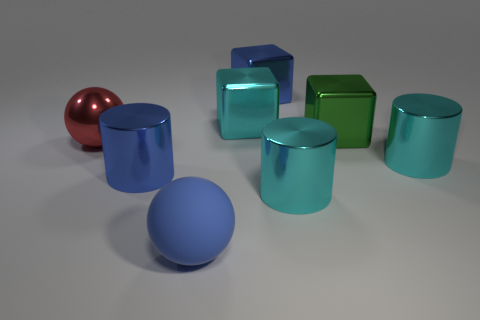Are there more small blocks than green blocks?
Your answer should be compact. No. Are there more things that are in front of the big cyan metallic cube than big red shiny spheres behind the large red metal ball?
Provide a short and direct response. Yes. There is a metallic cube that is both right of the cyan shiny block and in front of the big blue metal block; how big is it?
Provide a short and direct response. Large. How many cyan metal cylinders are the same size as the green cube?
Keep it short and to the point. 2. What is the material of the block that is the same color as the rubber sphere?
Offer a terse response. Metal. There is a blue object that is behind the large blue cylinder; is it the same shape as the large green object?
Your answer should be very brief. Yes. Is the number of big cyan metallic cylinders that are left of the red metal ball less than the number of yellow shiny cubes?
Provide a short and direct response. No. Are there any large matte blocks of the same color as the rubber thing?
Give a very brief answer. No. Does the blue matte object have the same shape as the cyan thing that is in front of the blue shiny cylinder?
Give a very brief answer. No. Is there a big cyan cube made of the same material as the red ball?
Your response must be concise. Yes. 